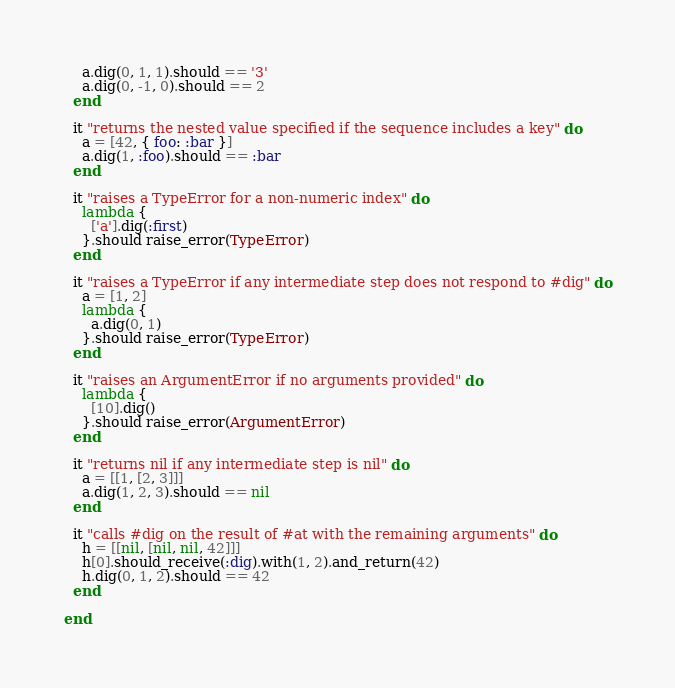<code> <loc_0><loc_0><loc_500><loc_500><_Ruby_>    a.dig(0, 1, 1).should == '3'
    a.dig(0, -1, 0).should == 2
  end

  it "returns the nested value specified if the sequence includes a key" do
    a = [42, { foo: :bar }]
    a.dig(1, :foo).should == :bar
  end

  it "raises a TypeError for a non-numeric index" do
    lambda {
      ['a'].dig(:first)
    }.should raise_error(TypeError)
  end

  it "raises a TypeError if any intermediate step does not respond to #dig" do
    a = [1, 2]
    lambda {
      a.dig(0, 1)
    }.should raise_error(TypeError)
  end

  it "raises an ArgumentError if no arguments provided" do
    lambda {
      [10].dig()
    }.should raise_error(ArgumentError)
  end

  it "returns nil if any intermediate step is nil" do
    a = [[1, [2, 3]]]
    a.dig(1, 2, 3).should == nil
  end

  it "calls #dig on the result of #at with the remaining arguments" do
    h = [[nil, [nil, nil, 42]]]
    h[0].should_receive(:dig).with(1, 2).and_return(42)
    h.dig(0, 1, 2).should == 42
  end

end
</code> 